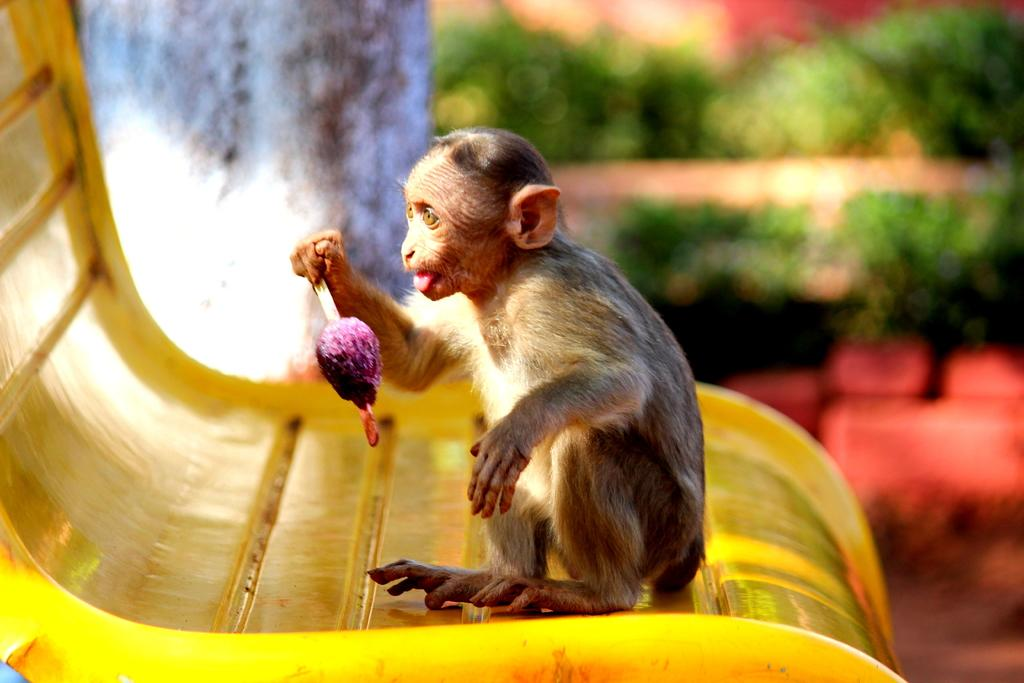What animal is in the picture? There is a monkey in the picture. Where is the monkey located? The monkey is on a chair. What is the monkey holding? The monkey is holding an ice cream. What can be seen in the background of the picture? There are plants in the background of the picture. What is on the left side of the picture? There appears to be a wall on the left side of the picture. What type of badge is the writer wearing in the image? There is no writer or badge present in the image; it features a monkey on a chair holding an ice cream. 